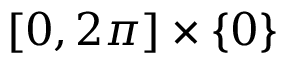Convert formula to latex. <formula><loc_0><loc_0><loc_500><loc_500>[ 0 , 2 \pi ] \times \{ 0 \}</formula> 